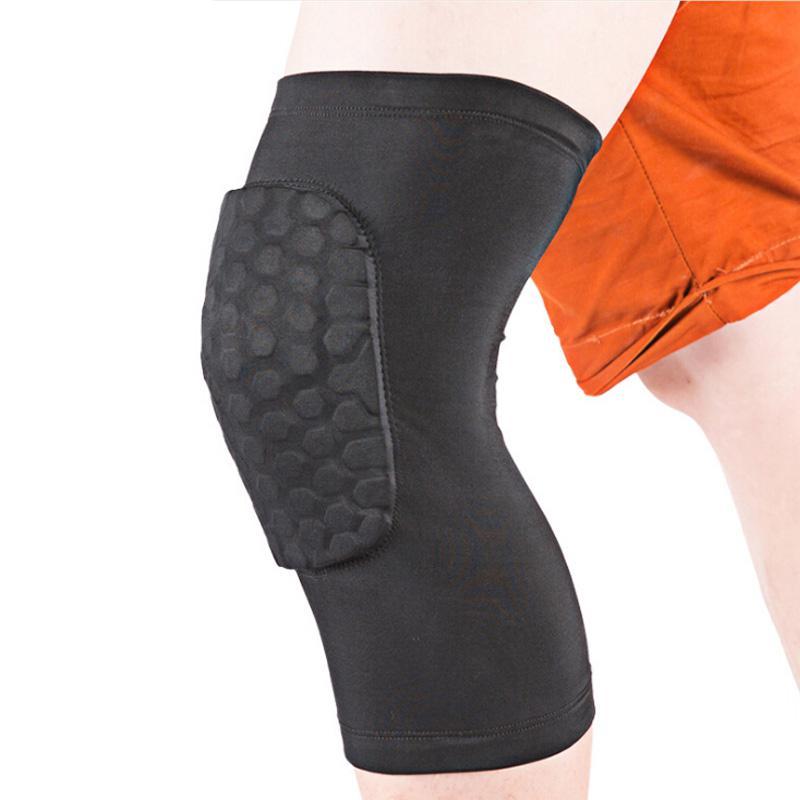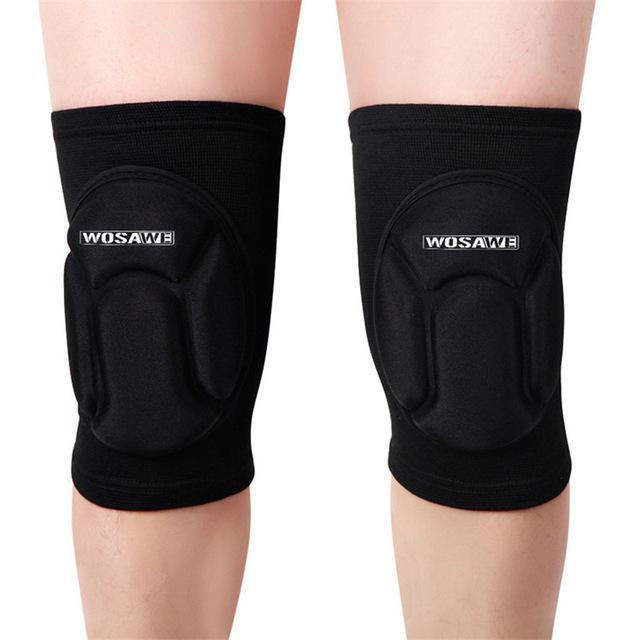The first image is the image on the left, the second image is the image on the right. For the images displayed, is the sentence "There are exactly two knee braces." factually correct? Answer yes or no. No. The first image is the image on the left, the second image is the image on the right. Analyze the images presented: Is the assertion "The right image contains no more than one knee brace." valid? Answer yes or no. No. 